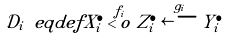<formula> <loc_0><loc_0><loc_500><loc_500>\mathcal { D } _ { i } \ e q d e f X ^ { \bullet } _ { i } \overset { f _ { i } } { < o } Z ^ { \bullet } _ { i } \overset { g _ { i } } { \longleftarrow } Y ^ { \bullet } _ { i }</formula> 